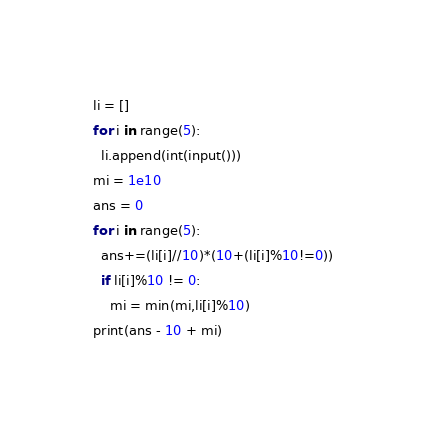<code> <loc_0><loc_0><loc_500><loc_500><_Python_>li = []
for i in range(5):
  li.append(int(input()))
mi = 1e10
ans = 0
for i in range(5):
  ans+=(li[i]//10)*(10+(li[i]%10!=0))
  if li[i]%10 != 0:
    mi = min(mi,li[i]%10)
print(ans - 10 + mi)</code> 